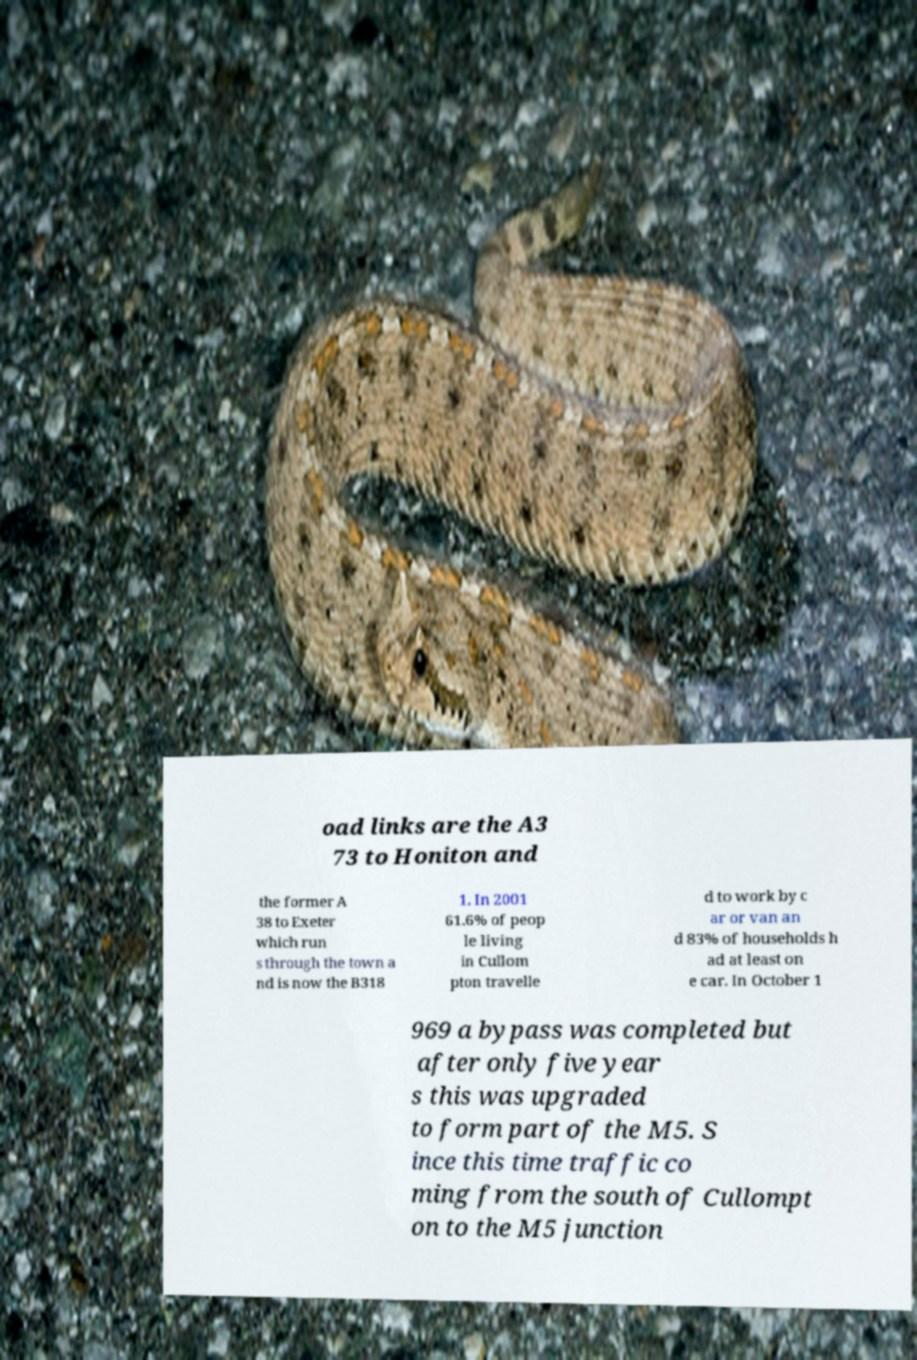Please identify and transcribe the text found in this image. oad links are the A3 73 to Honiton and the former A 38 to Exeter which run s through the town a nd is now the B318 1. In 2001 61.6% of peop le living in Cullom pton travelle d to work by c ar or van an d 83% of households h ad at least on e car. In October 1 969 a bypass was completed but after only five year s this was upgraded to form part of the M5. S ince this time traffic co ming from the south of Cullompt on to the M5 junction 